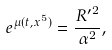<formula> <loc_0><loc_0><loc_500><loc_500>e ^ { \mu ( t , x ^ { 5 } ) } = \frac { { R ^ { \prime } } ^ { 2 } } { \alpha ^ { 2 } } ,</formula> 